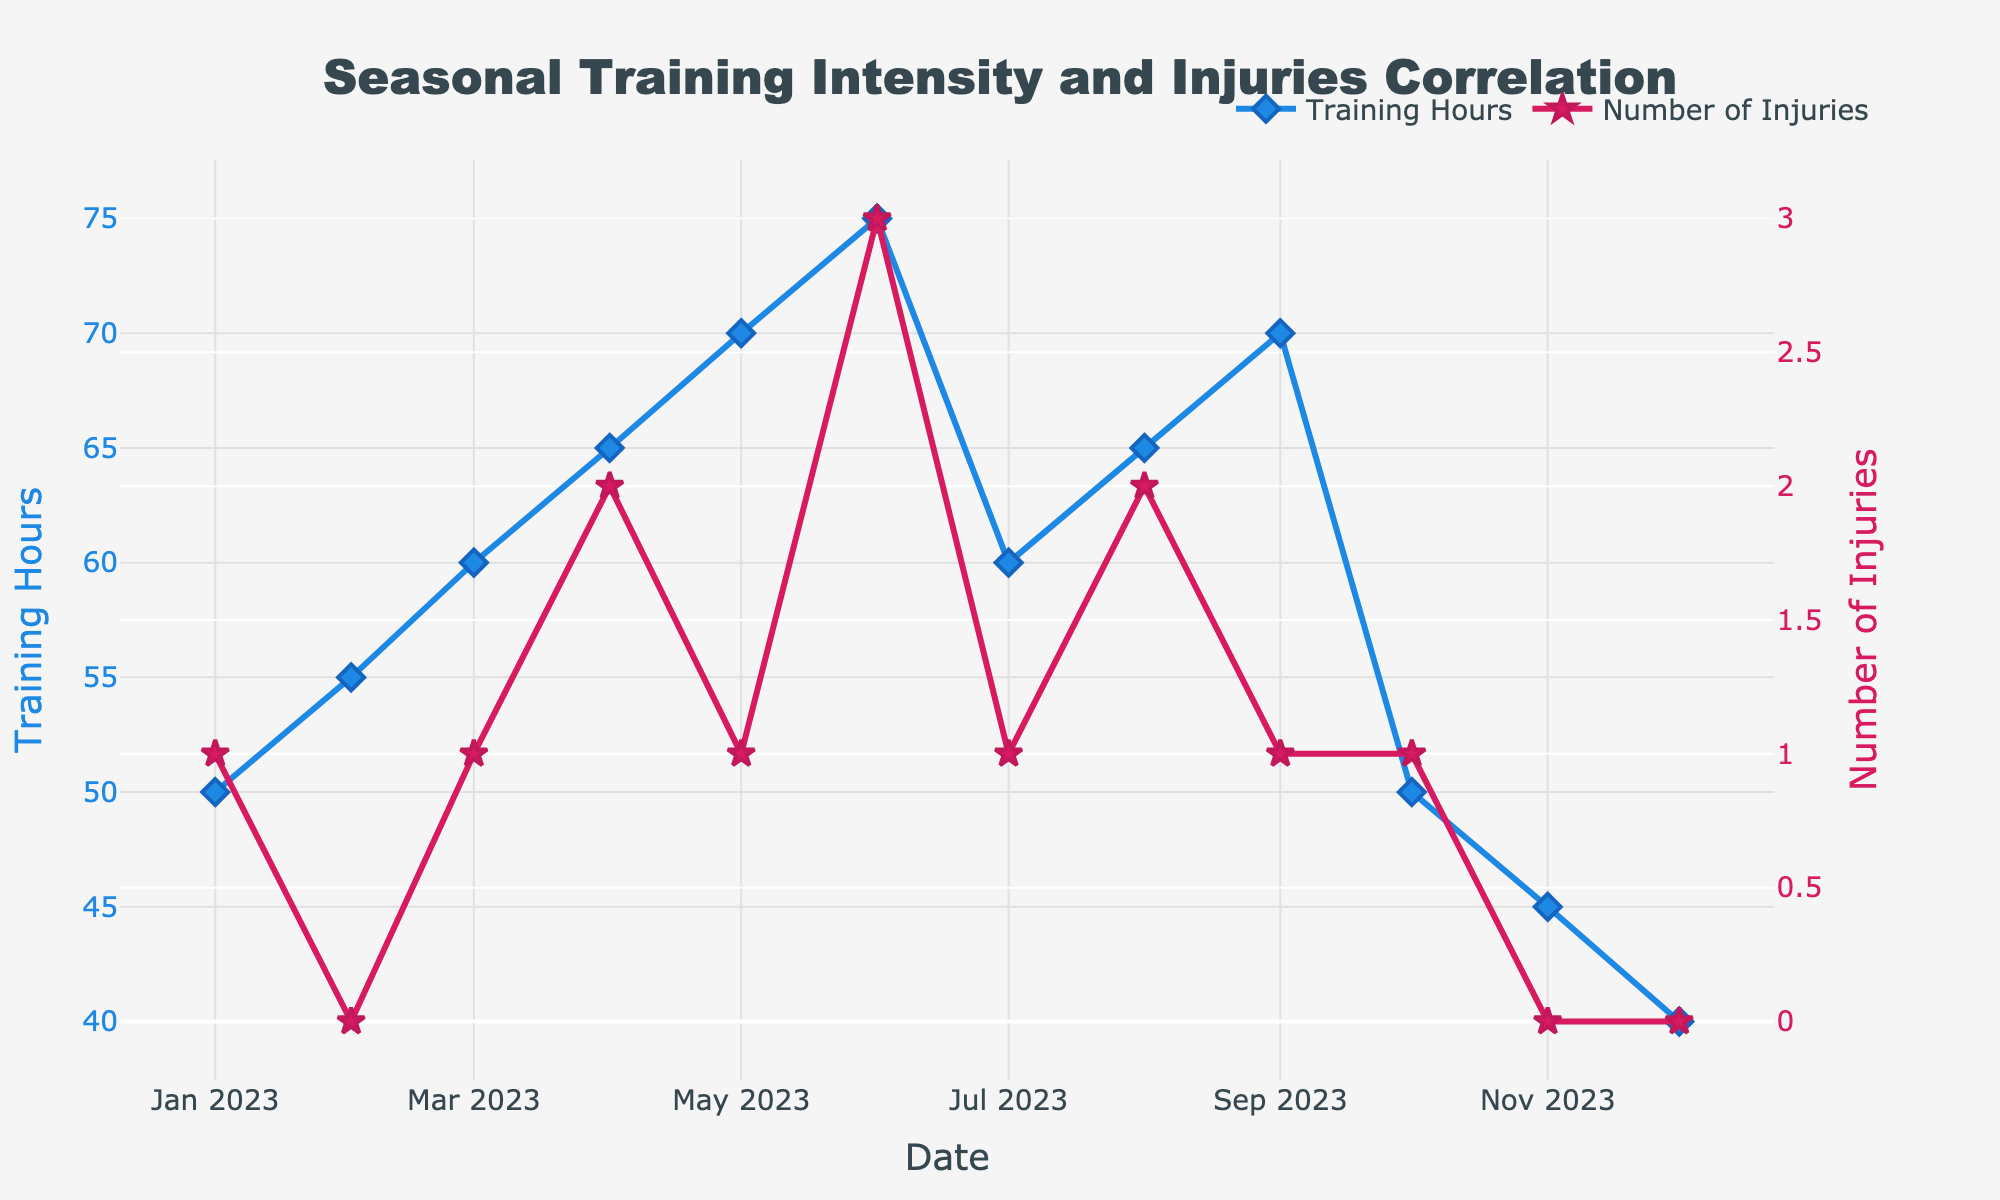What's the title of the figure? The title of the figure is displayed prominently at the top and reads "Seasonal Training Intensity and Injuries Correlation".
Answer: Seasonal Training Intensity and Injuries Correlation How many months are depicted in the figure? The x-axis in the figure represents dates with monthly intervals from January to December 2023. Counting the number of intervals shows 12 months.
Answer: 12 In which month did the highest training hours occur? Observing the line for "Training Hours", the highest peak is in June, where the value reaches 75 hours.
Answer: June Which month had the highest number of injuries? Checking the "Number of Injuries" line, the highest peak can be seen in June, where the number of injuries reaches 3.
Answer: June What is the trend in training hours from January to June? From January (50 hours) to June (75 hours), the training hours show a steadily increasing trend.
Answer: Increasing Compare the number of injuries between March and April. In the data series for "Number of Injuries", March had 1 injury, while April had 2 injuries. Thus, the number of injuries in April is higher than in March.
Answer: 2 in April, 1 in March Did the number of injuries increase or decrease from June to July? From June (3 injuries) to July (1 injury), the number of injuries decreased.
Answer: Decreased Compute the average training hours in the second half of the year (July to December). The training hours from July to December are 60, 65, 70, 50, 45, and 40 respectively. Summing these up gives 330 hours. Dividing by 6 yields the average: 330/6 = 55 hours.
Answer: 55 hours Is there a noticeable correlation between training hours and number of injuries? Observing both the "Training Hours" and the "Number of Injuries" lines, it's noticeable that months with higher training hours (like June) often correspond to higher numbers of injuries, suggesting a possible positive correlation.
Answer: Yes, a positive correlation How does the injury count in October compare to that in November? In October, there was 1 injury, while November had 0 injuries. Thus, the count in October is higher.
Answer: October: 1, November: 0 